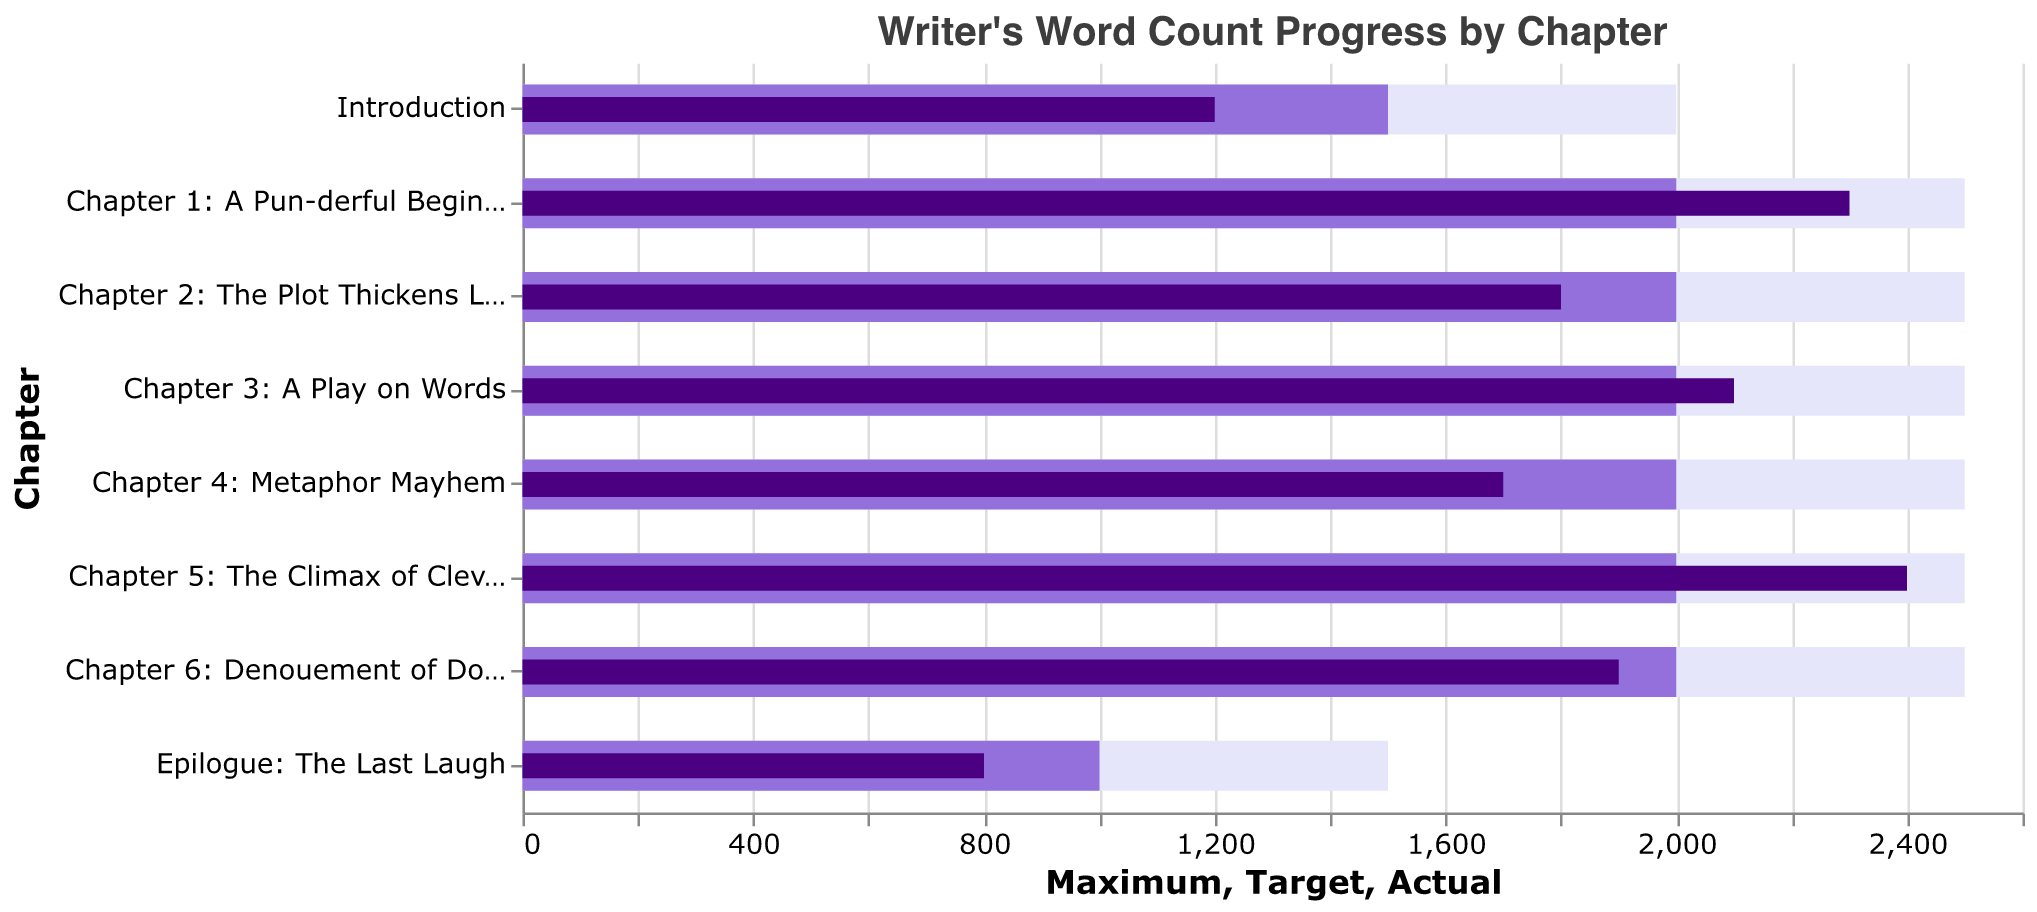Which chapter has the highest actual word count? Identify the bars representing actual word counts and find the tallest one. "Chapter 5: The Climax of Cleverness" has the highest bar with an actual count of 2400 words.
Answer: Chapter 5: The Climax of Cleverness How many chapters have an actual word count that exceeds their target? Compare each chapter's actual word count bar with the target word count bar. Chapters that meet this criterion are: "Chapter 1: A Pun-derful Beginning" (2300 > 2000), "Chapter 3: A Play on Words" (2100 > 2000), and "Chapter 5: The Climax of Cleverness" (2400 > 2000).
Answer: Three chapters Which chapter has the largest gap between the actual word count and the target word count? Subtract the target word count from the actual word count for each chapter. The chapter with the largest positive difference is "Chapter 1: A Pun-derful Beginning" (2300 - 2000 = 300).
Answer: Chapter 1: A Pun-derful Beginning How many chapters did not meet their maximum word count? Compare the actual word count of each chapter to its maximum word count. Chapters that did not meet this criterion are: "Introduction" (1200 < 2000), "Chapter 2: The Plot Thickens Like Alphabet Soup" (1800 < 2500), "Chapter 4: Metaphor Mayhem" (1700 < 2500), "Chapter 6: Denouement of Double Entendres" (1900 < 2500), and "Epilogue: The Last Laugh" (800 < 1500).
Answer: Five chapters What is the average actual word count across all chapters? Sum all the actual word counts and divide by the number of chapters. The total actual word count is (1200 + 2300 + 1800 + 2100 + 1700 + 2400 + 1900 + 800) = 14200, and there are 8 chapters. So, the average is 14200 / 8 = 1775 words.
Answer: 1775 words Which chapter has the lowest actual word count, and what is it? Identify the bar representing the smallest actual word count. "Epilogue: The Last Laugh" has the lowest bar with an actual count of 800 words.
Answer: Epilogue: The Last Laugh, 800 words In which chapter does the actual word count fall the most short of the target? Subtract the actual word count from the target word count for each chapter. The chapter with the largest negative difference is "Introduction" (1200 - 1500 = -300).
Answer: Introduction What is the total target word count for all chapters combined? Sum all the target word counts. The total target word count is 1500 + 2000 + 2000 + 2000 + 2000 + 2000 + 2000 + 1000 = 14500.
Answer: 14500 words What percentage of the target word count has been achieved for "Chapter 3: A Play on Words"? Divide the actual word count by the target word count and multiply by 100. For "Chapter 3: A Play on Words", it is (2100 / 2000) * 100 = 105%.
Answer: 105% 